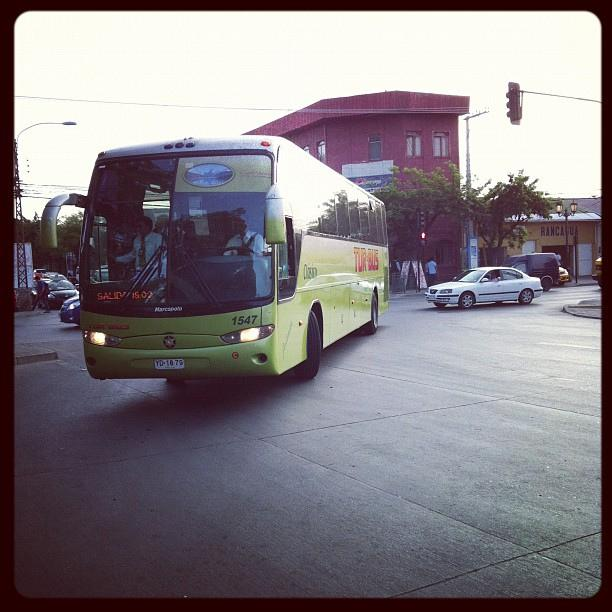What make of vehicle is following the bus? Please explain your reasoning. hyundai. A small white sedan is following a bus. the emblem has a h on the front grill. 